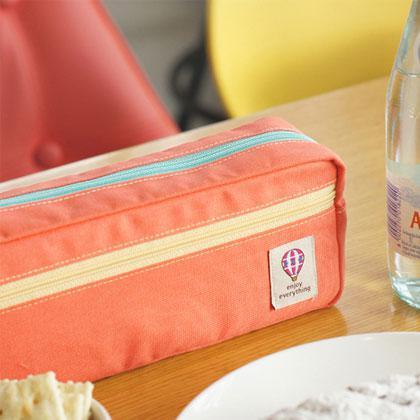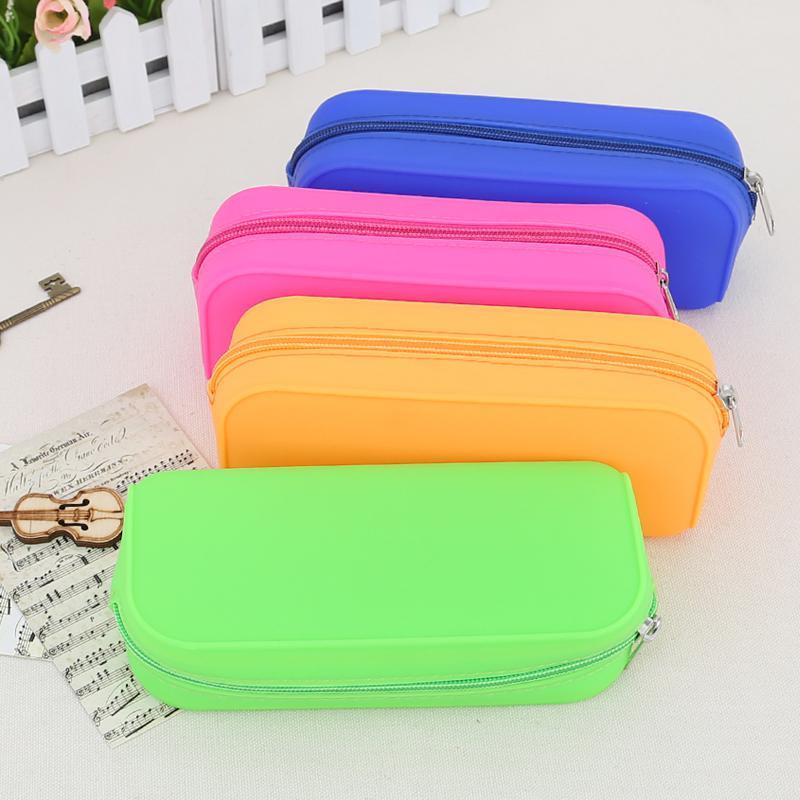The first image is the image on the left, the second image is the image on the right. Assess this claim about the two images: "The image on the right contains no more than four handbags that are each a different color.". Correct or not? Answer yes or no. Yes. 